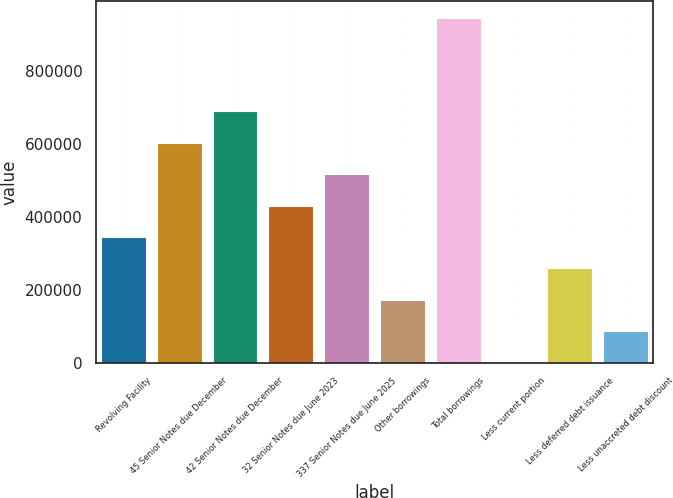Convert chart. <chart><loc_0><loc_0><loc_500><loc_500><bar_chart><fcel>Revolving Facility<fcel>45 Senior Notes due December<fcel>42 Senior Notes due December<fcel>32 Senior Notes due June 2023<fcel>337 Senior Notes due June 2025<fcel>Other borrowings<fcel>Total borrowings<fcel>Less current portion<fcel>Less deferred debt issuance<fcel>Less unaccreted debt discount<nl><fcel>345029<fcel>603608<fcel>689800<fcel>431222<fcel>517415<fcel>172644<fcel>944981<fcel>258<fcel>258836<fcel>86450.8<nl></chart> 